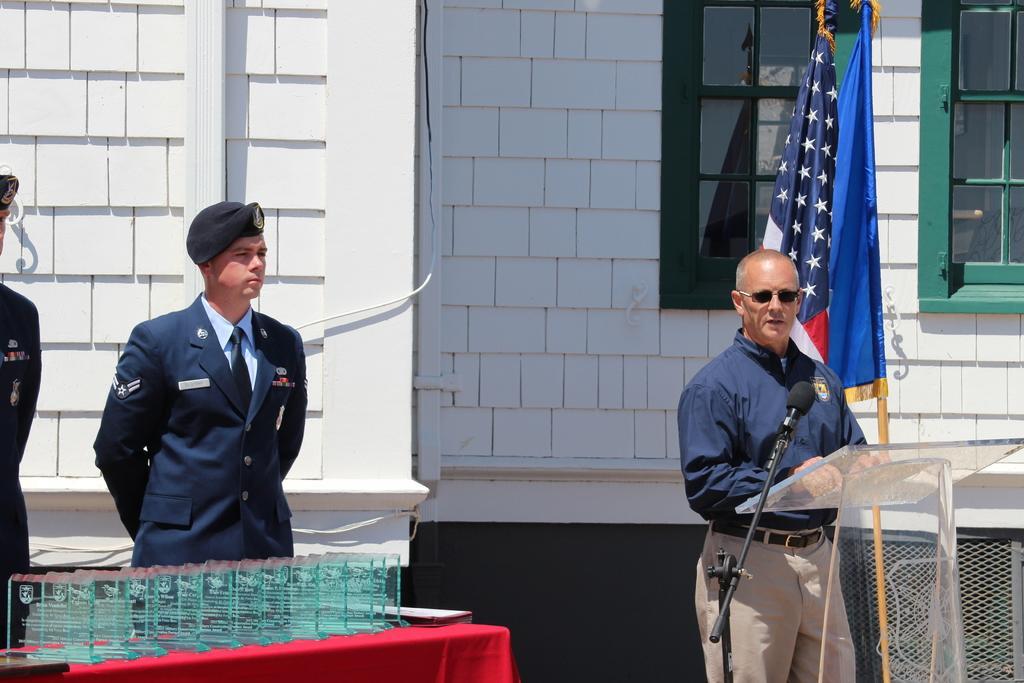Describe this image in one or two sentences. In this picture we can see three people where a man standing at the podium, mic stand, glass shields and a red cloth on the table, flags, windows and in the background we can see the wall. 